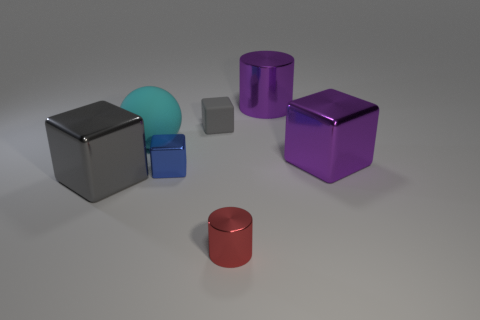How many tiny objects are either spheres or purple matte blocks? In the image, there is one sphere that appears to be small and turquoise in color. There are two matte blocks, one is purple, and the other is not tiny but rather a medium size and gray. If we focus only on the tiny objects as specified in your question and consider only the purple matte block and not the sphere (since it's not purple), the count would be one. 